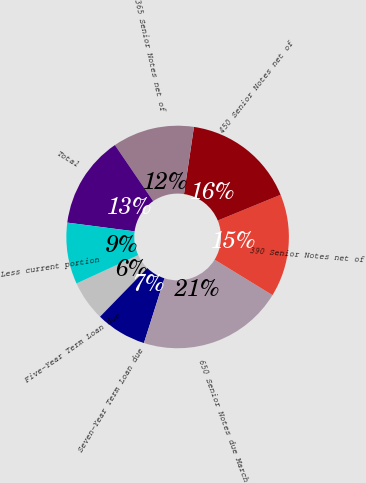<chart> <loc_0><loc_0><loc_500><loc_500><pie_chart><fcel>Five-Year Term Loan due<fcel>Seven-Year Term Loan due<fcel>650 Senior Notes due March<fcel>390 Senior Notes net of<fcel>450 Senior Notes net of<fcel>365 Senior Notes net of<fcel>Total<fcel>Less current portion<nl><fcel>5.86%<fcel>7.39%<fcel>21.15%<fcel>14.94%<fcel>16.47%<fcel>11.88%<fcel>13.41%<fcel>8.92%<nl></chart> 